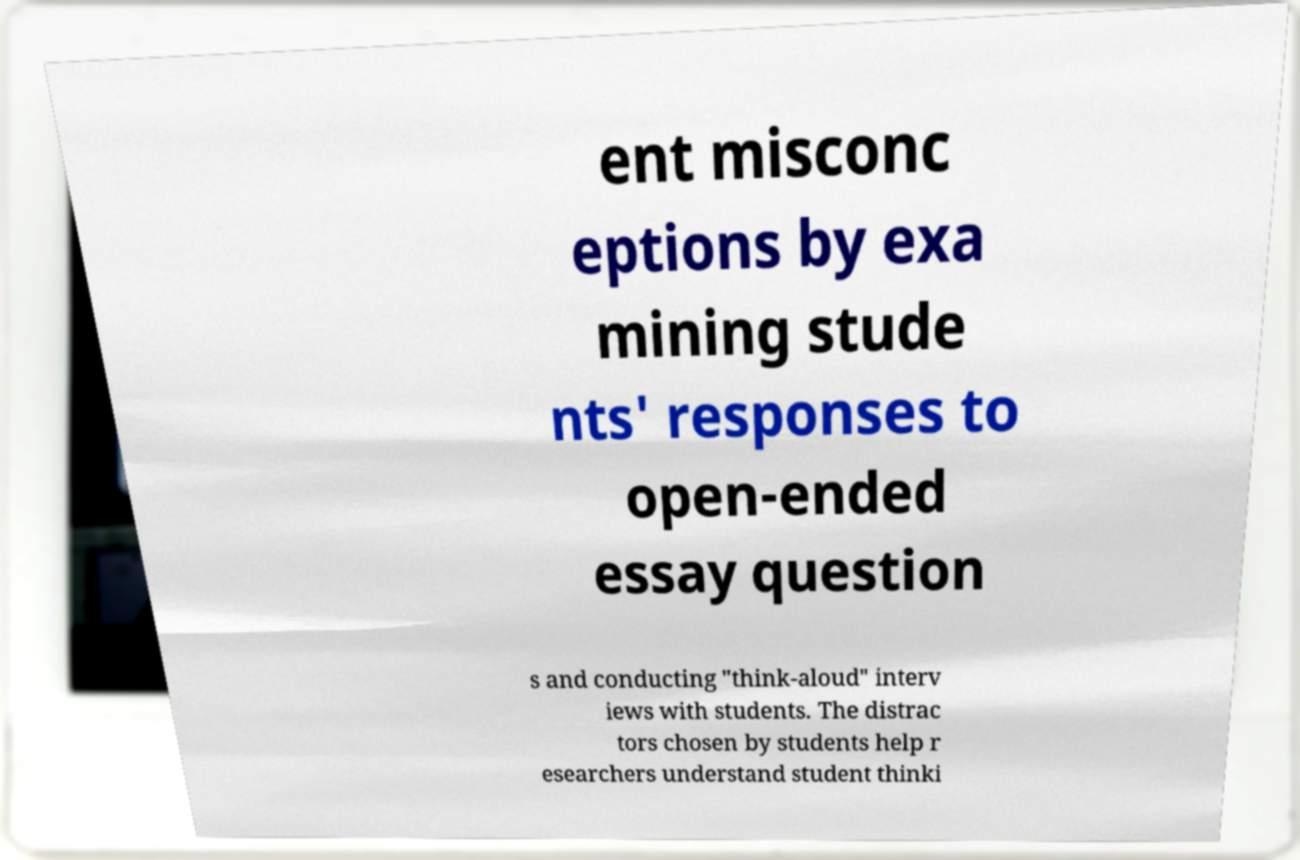Please read and relay the text visible in this image. What does it say? ent misconc eptions by exa mining stude nts' responses to open-ended essay question s and conducting "think-aloud" interv iews with students. The distrac tors chosen by students help r esearchers understand student thinki 